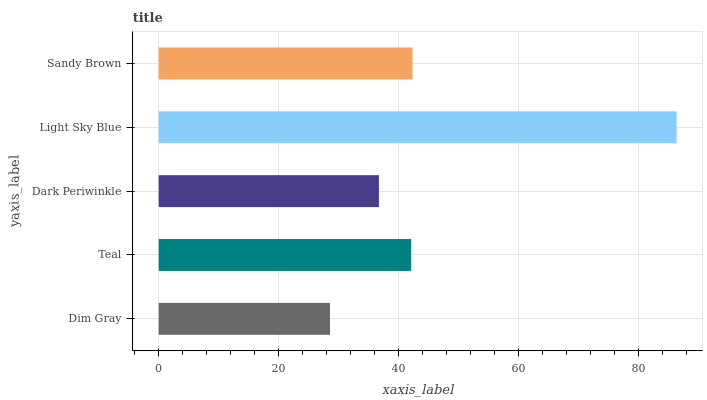Is Dim Gray the minimum?
Answer yes or no. Yes. Is Light Sky Blue the maximum?
Answer yes or no. Yes. Is Teal the minimum?
Answer yes or no. No. Is Teal the maximum?
Answer yes or no. No. Is Teal greater than Dim Gray?
Answer yes or no. Yes. Is Dim Gray less than Teal?
Answer yes or no. Yes. Is Dim Gray greater than Teal?
Answer yes or no. No. Is Teal less than Dim Gray?
Answer yes or no. No. Is Teal the high median?
Answer yes or no. Yes. Is Teal the low median?
Answer yes or no. Yes. Is Sandy Brown the high median?
Answer yes or no. No. Is Light Sky Blue the low median?
Answer yes or no. No. 